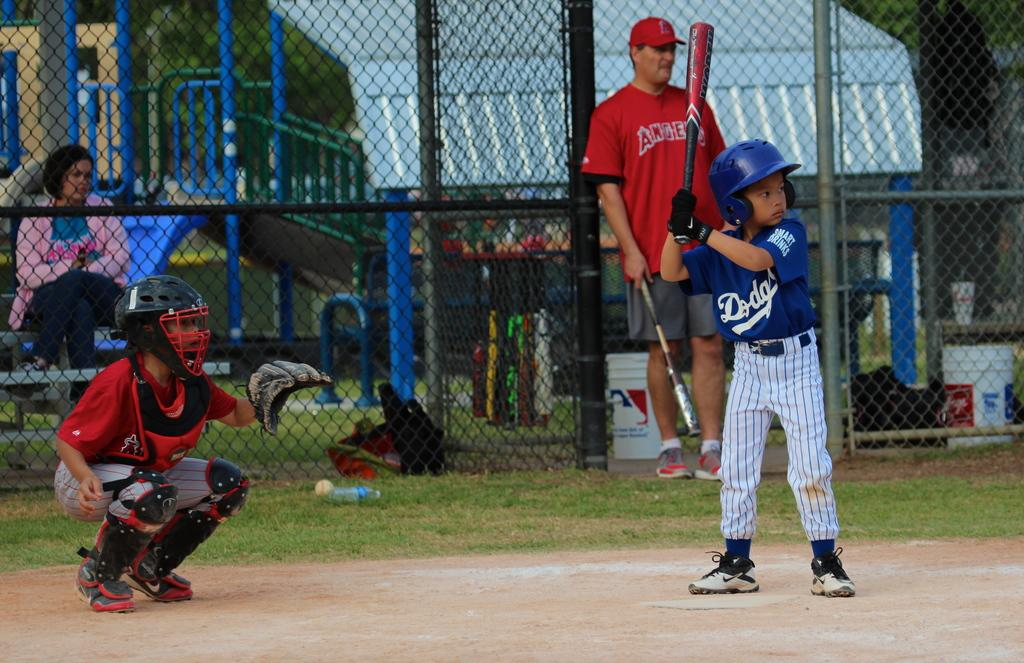<image>
Share a concise interpretation of the image provided. A little boy wearing a Dodgers shirt is up at bat. 